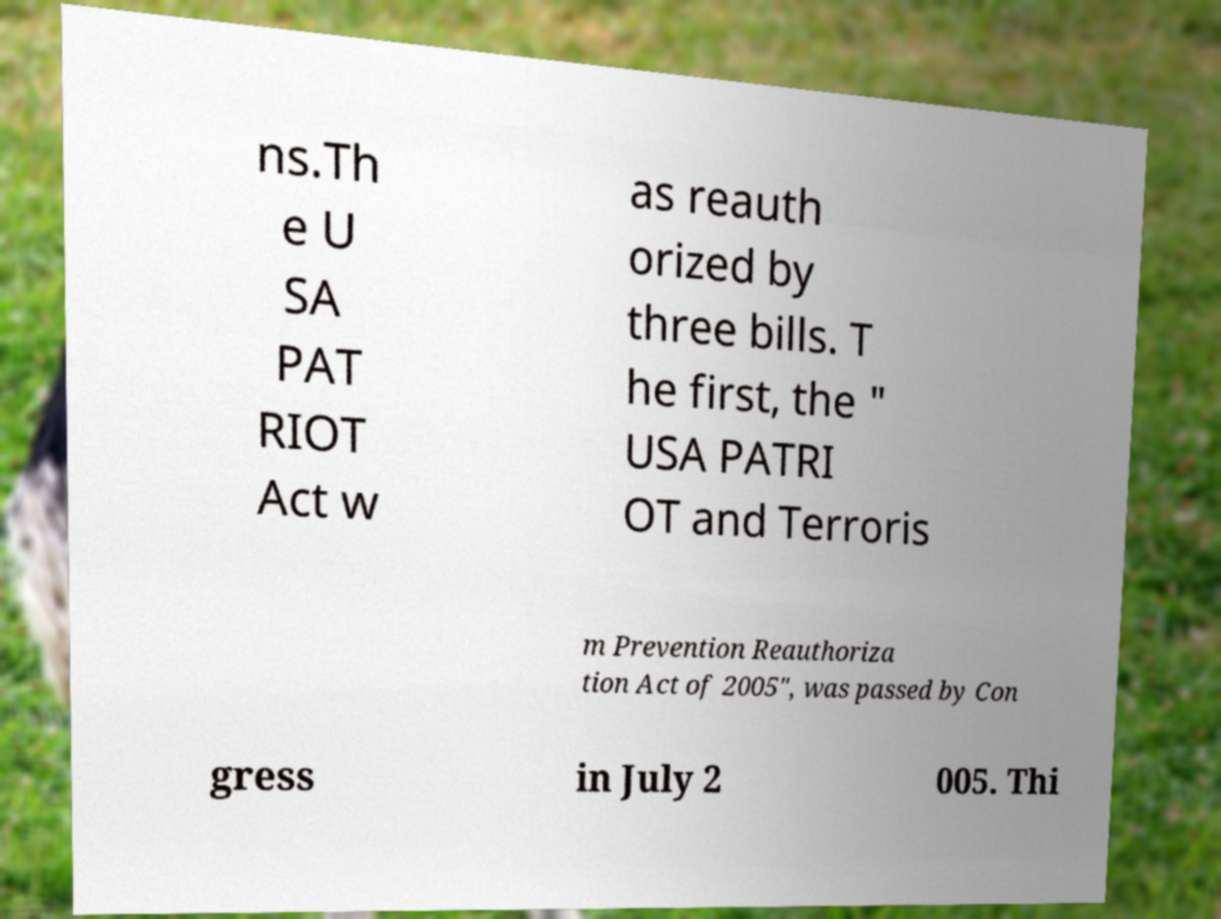Could you assist in decoding the text presented in this image and type it out clearly? ns.Th e U SA PAT RIOT Act w as reauth orized by three bills. T he first, the " USA PATRI OT and Terroris m Prevention Reauthoriza tion Act of 2005", was passed by Con gress in July 2 005. Thi 